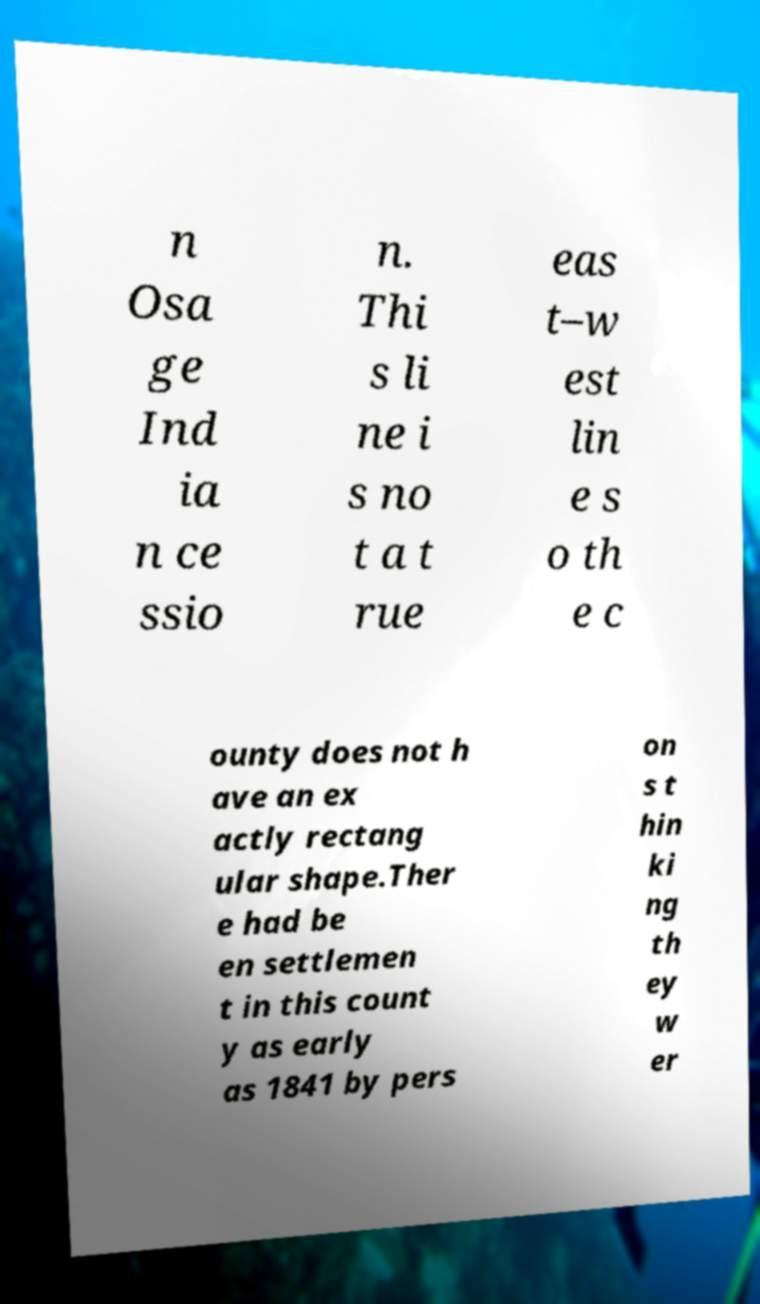Could you extract and type out the text from this image? n Osa ge Ind ia n ce ssio n. Thi s li ne i s no t a t rue eas t–w est lin e s o th e c ounty does not h ave an ex actly rectang ular shape.Ther e had be en settlemen t in this count y as early as 1841 by pers on s t hin ki ng th ey w er 